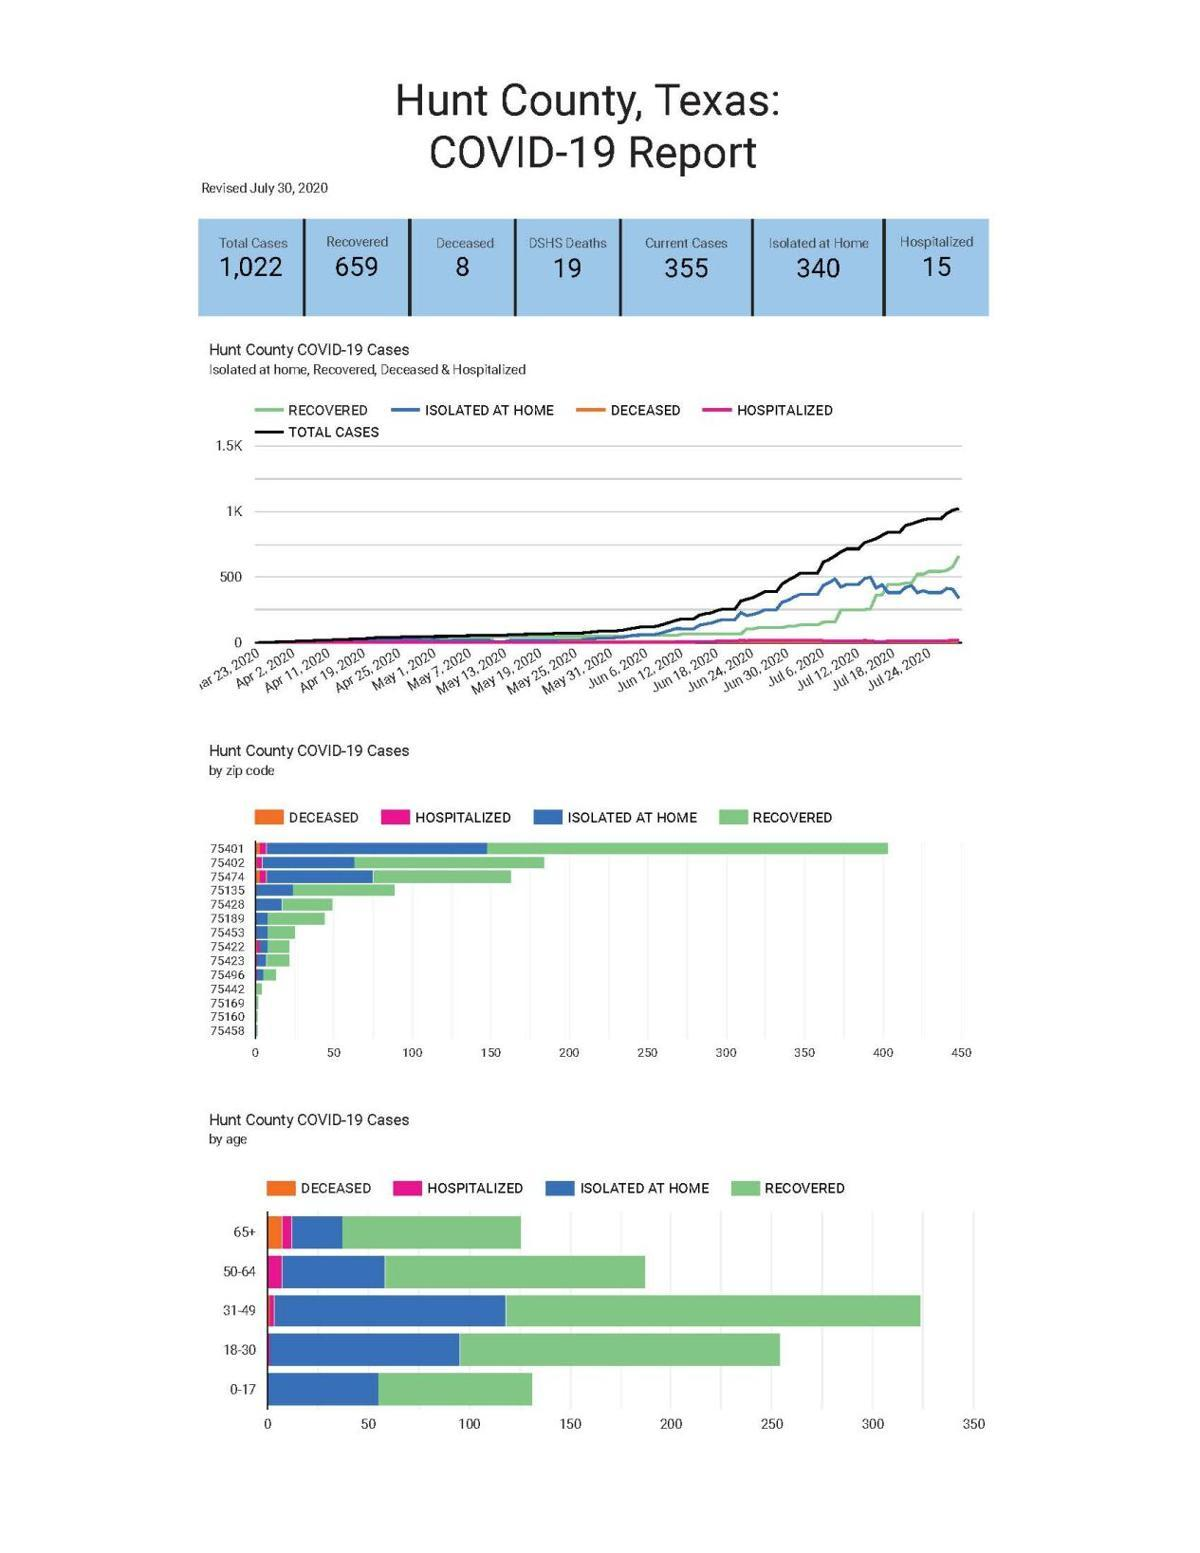List a handful of essential elements in this visual. The difference between total cases and the current cases as of July 30 is 667. As of July 30, there is a difference between the total cases and the deceased, with 1014 cases reported. As of July 30, the difference between total cases and recovered is 363. 